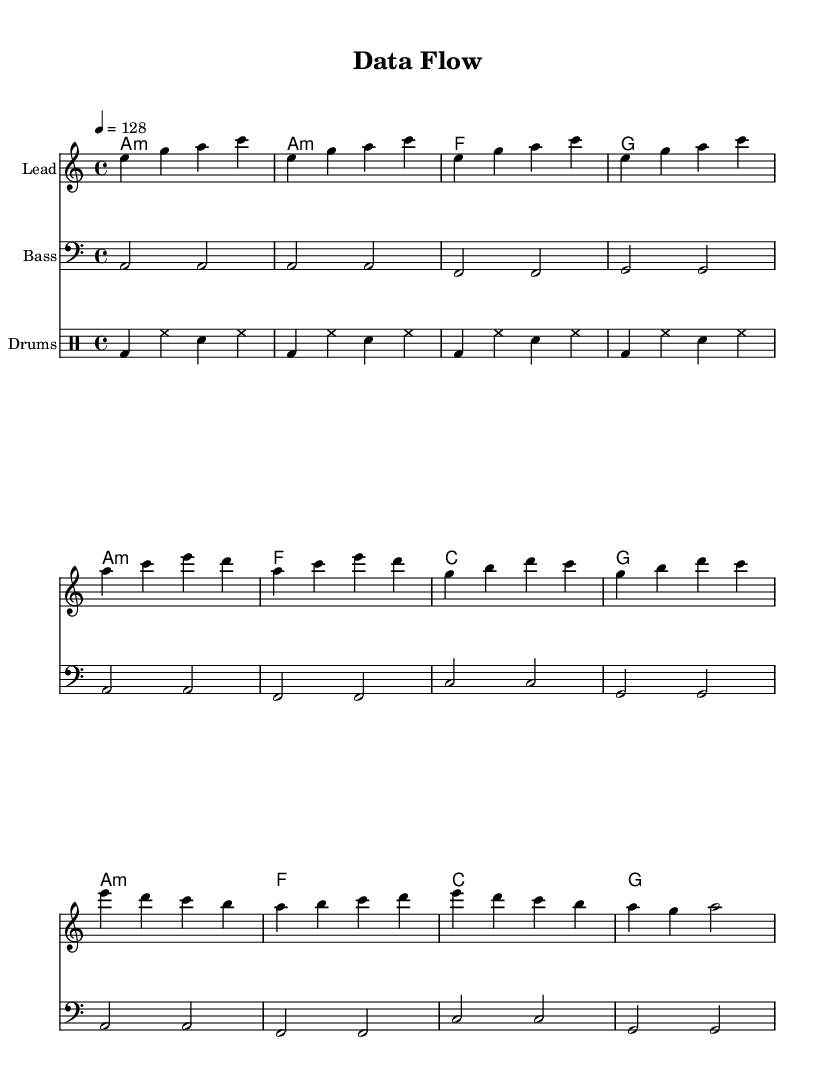What is the key signature of this music? The key signature is indicated by the key at the beginning of the score, which is A minor. A minor has no sharps or flats.
Answer: A minor What is the time signature of this music? The time signature is found at the beginning of the score, expressed as 4/4, indicating four beats in each measure.
Answer: 4/4 What is the tempo of the piece? The tempo is marked at the beginning of the score as a quarter note equals 128 beats per minute, which indicates a lively speed.
Answer: 128 What is the main theme of the chorus lyrics? The lyrics of the chorus emphasize the idea of data flowing and connectivity facilitated by APIs, indicating a central thematic focus on integration.
Answer: Data flow, oh data flow How many measures are in the intro section? The number of measures in the intro can be counted from the score, which shows 4 measures of music in the introduction.
Answer: 4 How does the bassline relate to the melody? The bassline provides harmonic support for the melody, typically playing root notes of the chords, complementing the melody's structure.
Answer: Supports melody What type of rhythm pattern is used in the drum part? The drum pattern is simplified and consists of a basic kick-snare hi-hat rhythm, typical for electronic dance music, creating a steady driving beat.
Answer: Kick-snare hi-hat 